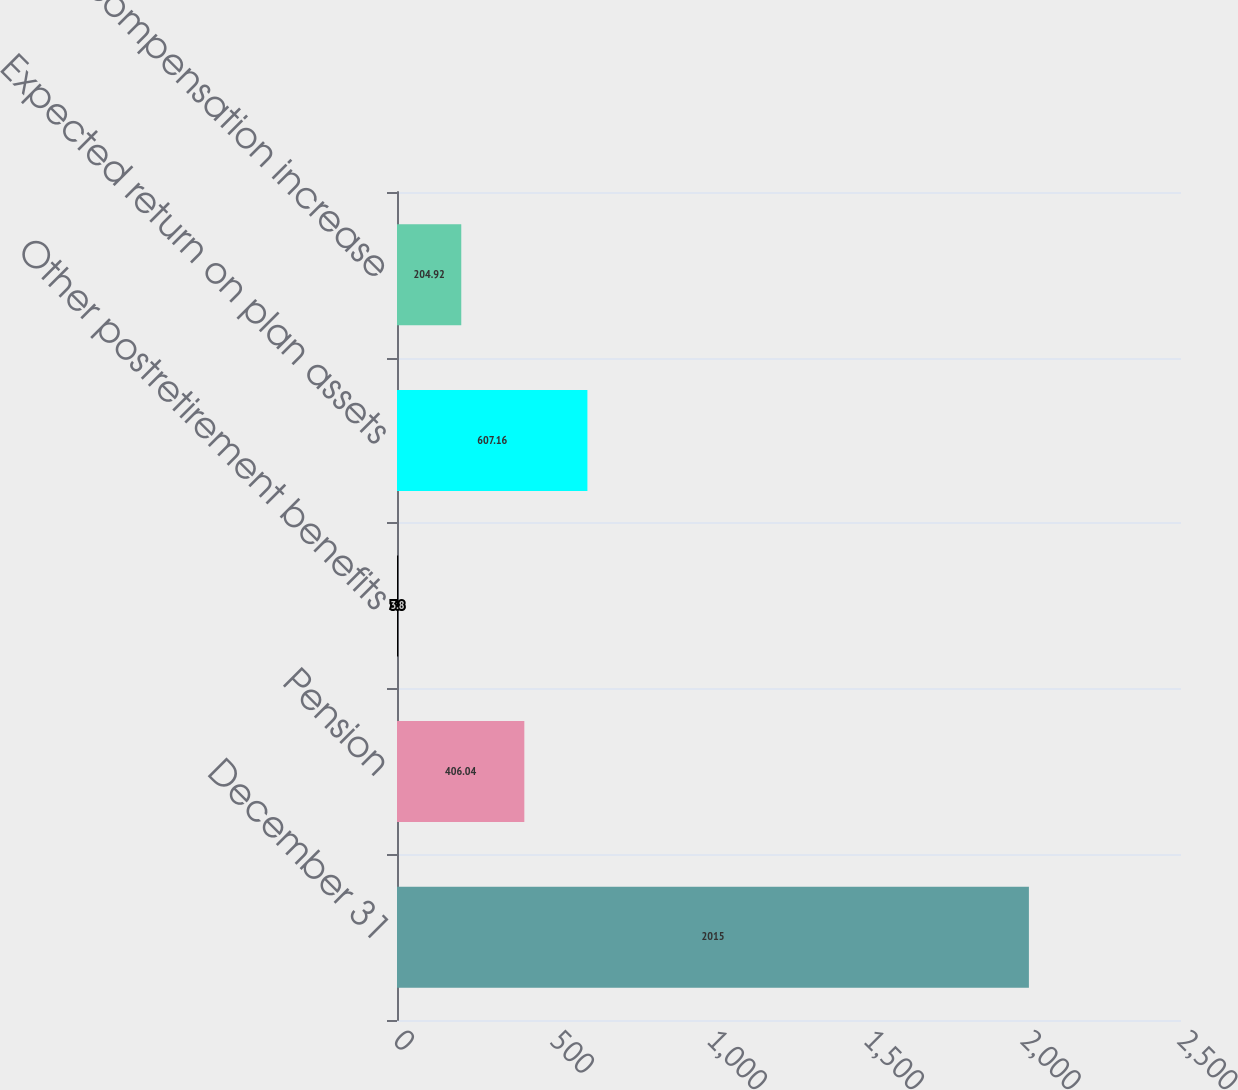Convert chart to OTSL. <chart><loc_0><loc_0><loc_500><loc_500><bar_chart><fcel>December 31<fcel>Pension<fcel>Other postretirement benefits<fcel>Expected return on plan assets<fcel>Rate of compensation increase<nl><fcel>2015<fcel>406.04<fcel>3.8<fcel>607.16<fcel>204.92<nl></chart> 